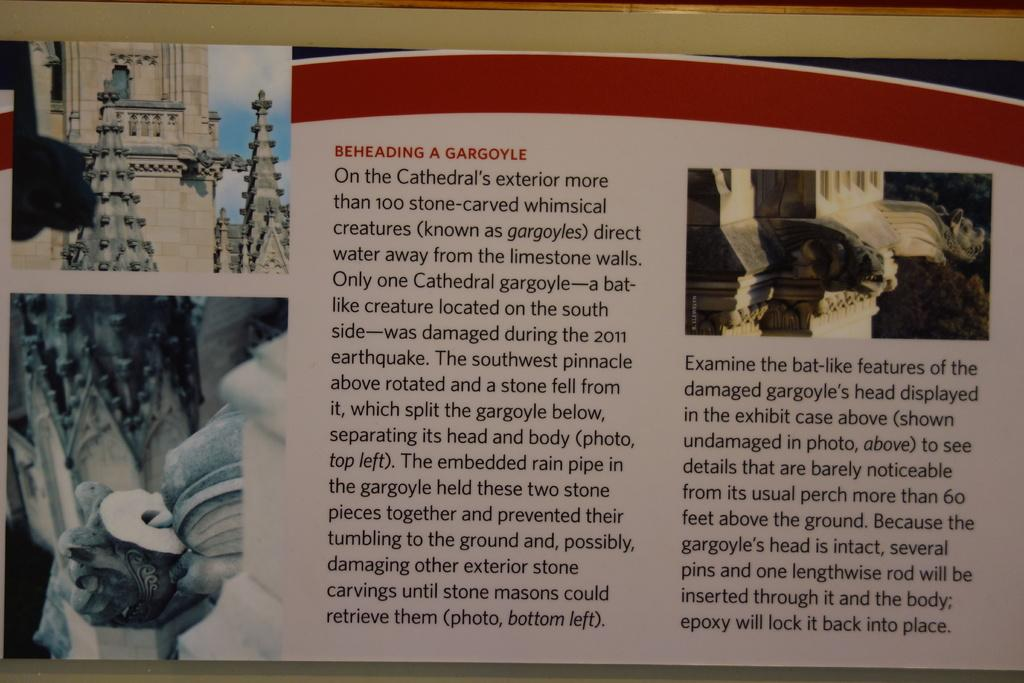<image>
Offer a succinct explanation of the picture presented. a red and white information card about beheading a gargoyle 